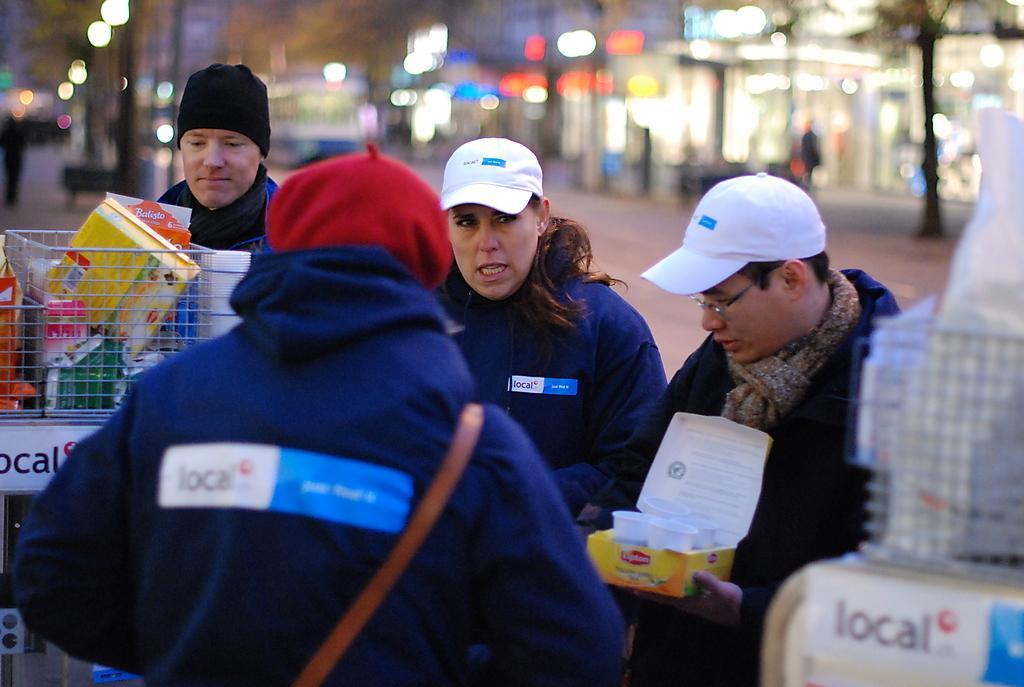Please provide a concise description of this image. In the image there are few person in navy blue jackets standing in the middle with basket on the left side with groceries in it, in the back there are buildings and on the right side with lights and on the left side there are street lights. 